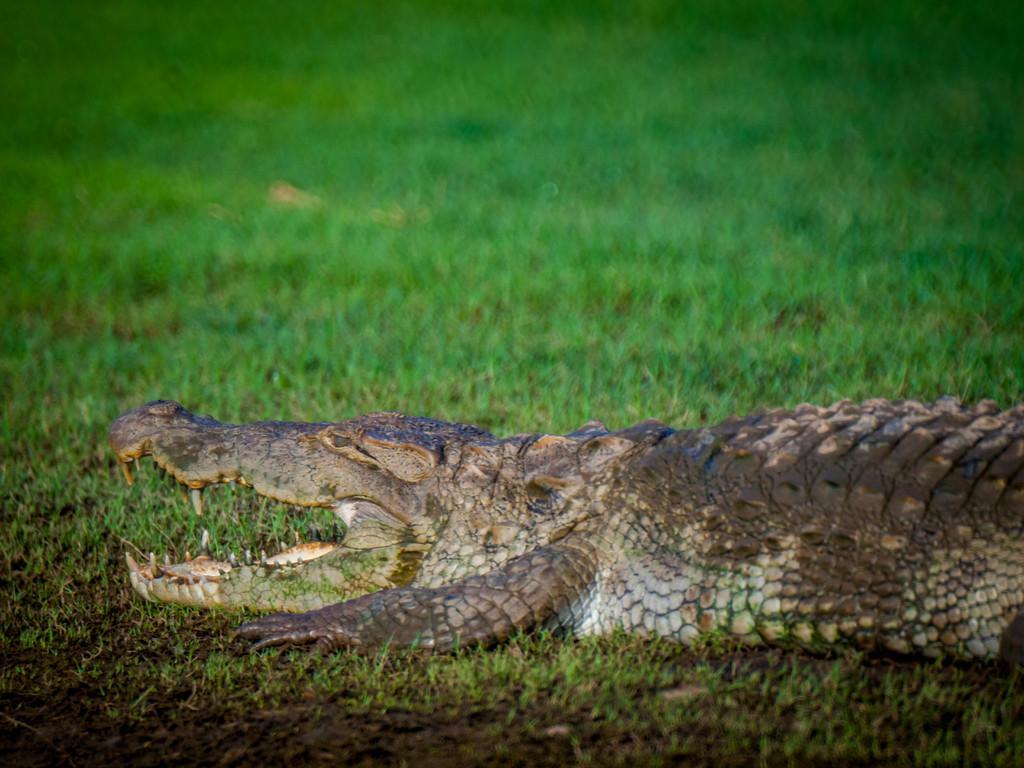Please provide a concise description of this image. In this image there is a crocodile on the surface of the grass. 